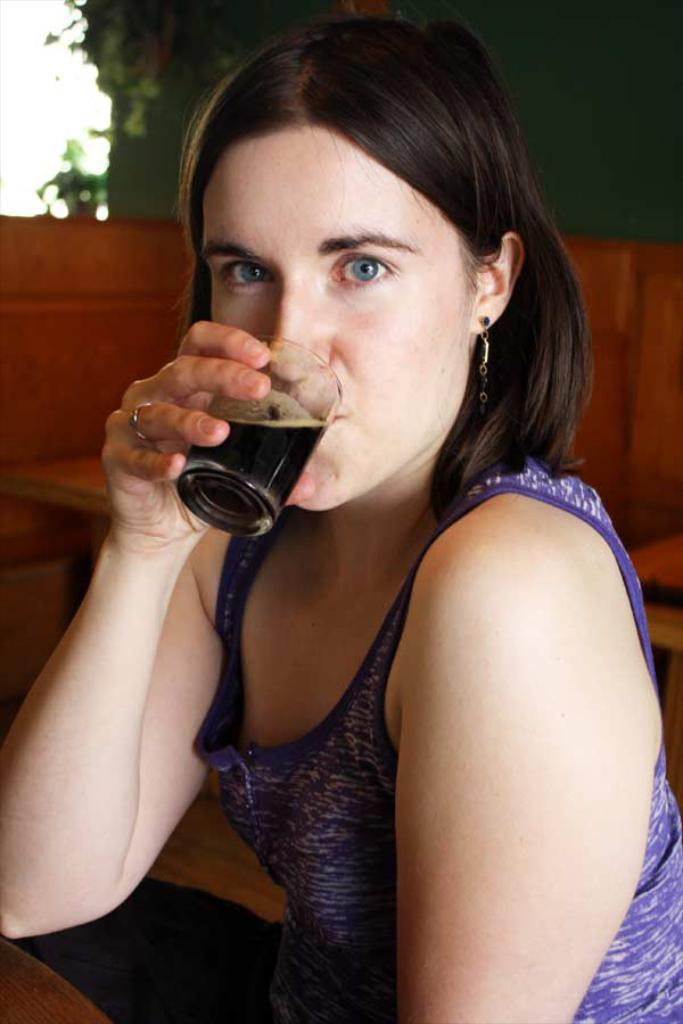Who is present in the image? There is a woman in the image. What is the woman doing? The woman is having a drink. What type of goat can be seen in the image? There is no goat present in the image. 